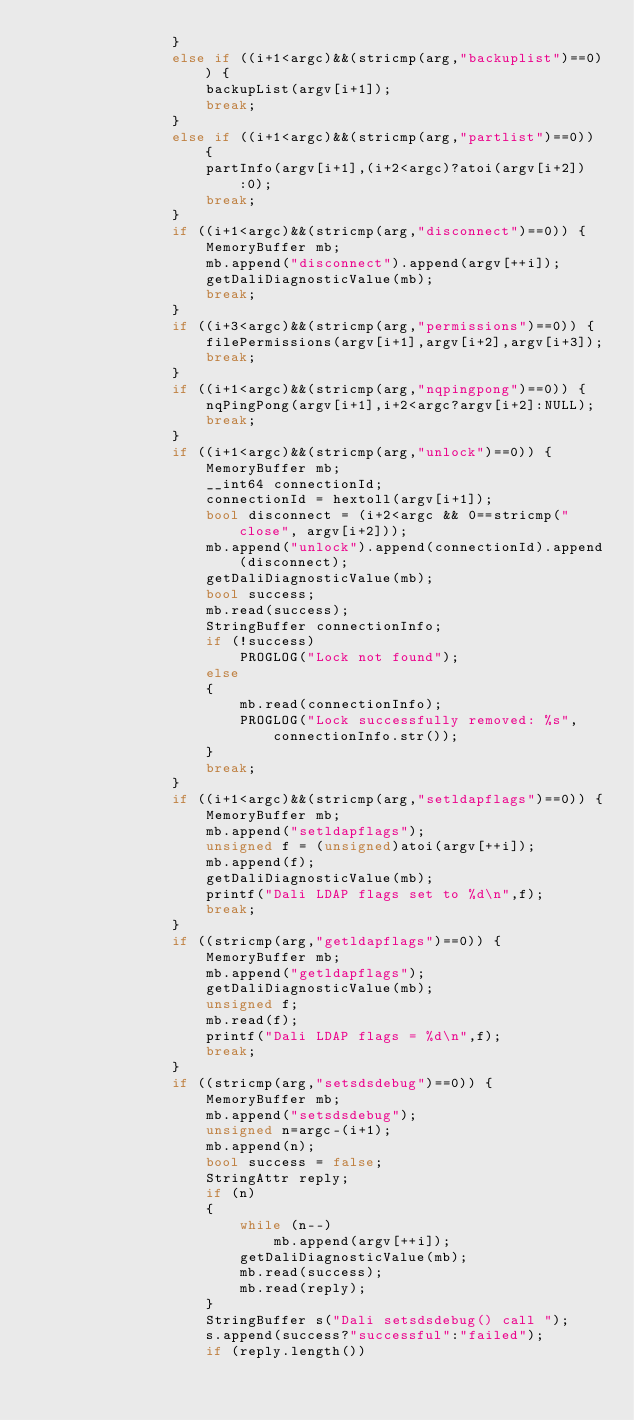Convert code to text. <code><loc_0><loc_0><loc_500><loc_500><_C++_>                }
                else if ((i+1<argc)&&(stricmp(arg,"backuplist")==0)) {
                    backupList(argv[i+1]);
                    break;
                }
                else if ((i+1<argc)&&(stricmp(arg,"partlist")==0)) {
                    partInfo(argv[i+1],(i+2<argc)?atoi(argv[i+2]):0);
                    break;
                }
                if ((i+1<argc)&&(stricmp(arg,"disconnect")==0)) {
                    MemoryBuffer mb;
                    mb.append("disconnect").append(argv[++i]);
                    getDaliDiagnosticValue(mb);
                    break;
                }
                if ((i+3<argc)&&(stricmp(arg,"permissions")==0)) {
                    filePermissions(argv[i+1],argv[i+2],argv[i+3]);
                    break;
                }
                if ((i+1<argc)&&(stricmp(arg,"nqpingpong")==0)) {
                    nqPingPong(argv[i+1],i+2<argc?argv[i+2]:NULL);
                    break;
                }
                if ((i+1<argc)&&(stricmp(arg,"unlock")==0)) {
                    MemoryBuffer mb;
                    __int64 connectionId;
                    connectionId = hextoll(argv[i+1]);
                    bool disconnect = (i+2<argc && 0==stricmp("close", argv[i+2]));
                    mb.append("unlock").append(connectionId).append(disconnect);
                    getDaliDiagnosticValue(mb);
                    bool success;
                    mb.read(success);
                    StringBuffer connectionInfo;
                    if (!success)
                        PROGLOG("Lock not found");
                    else
                    {
                        mb.read(connectionInfo);
                        PROGLOG("Lock successfully removed: %s", connectionInfo.str());
                    }
                    break;
                }
                if ((i+1<argc)&&(stricmp(arg,"setldapflags")==0)) {
                    MemoryBuffer mb;
                    mb.append("setldapflags");
                    unsigned f = (unsigned)atoi(argv[++i]);
                    mb.append(f);
                    getDaliDiagnosticValue(mb);
                    printf("Dali LDAP flags set to %d\n",f);
                    break;
                }
                if ((stricmp(arg,"getldapflags")==0)) {
                    MemoryBuffer mb;
                    mb.append("getldapflags");
                    getDaliDiagnosticValue(mb);
                    unsigned f;
                    mb.read(f);
                    printf("Dali LDAP flags = %d\n",f);
                    break;
                }
                if ((stricmp(arg,"setsdsdebug")==0)) {
                    MemoryBuffer mb;
                    mb.append("setsdsdebug");
                    unsigned n=argc-(i+1);
                    mb.append(n);
                    bool success = false;
                    StringAttr reply;
                    if (n)
                    {
                        while (n--)
                            mb.append(argv[++i]);
                        getDaliDiagnosticValue(mb);
                        mb.read(success);
                        mb.read(reply);
                    }
                    StringBuffer s("Dali setsdsdebug() call ");
                    s.append(success?"successful":"failed");
                    if (reply.length())</code> 